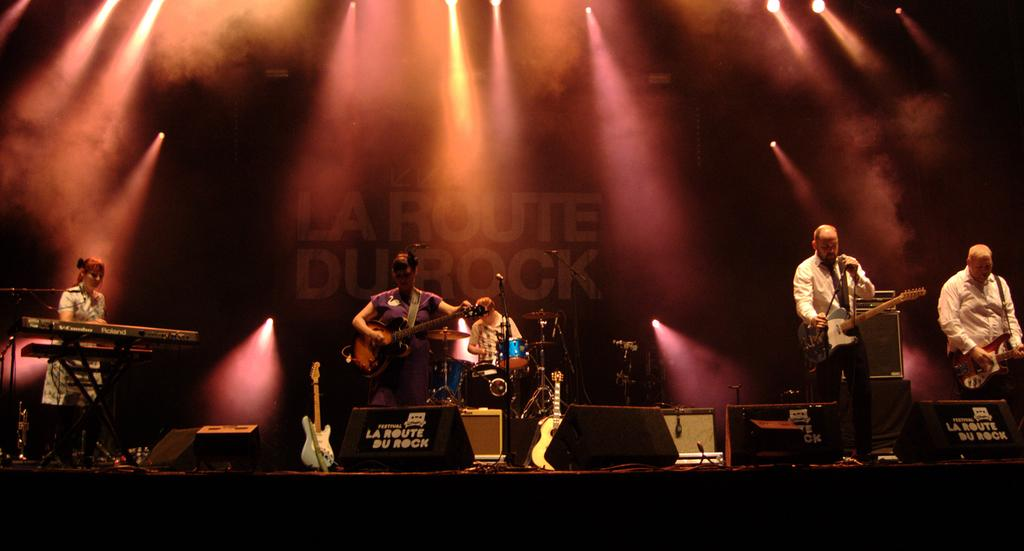What are the persons in the image doing? The persons in the image are standing and holding musical instruments. What else can be seen in the image besides the persons holding musical instruments? There are musical instruments in the background of the image. Can you describe the person in the background of the image? There is a person in the background of the image, but no specific details about them are provided. What can be seen in the background of the image that is not a person or musical instrument? There are lights visible in the background of the image. What type of cushion is being used for the activity in the image? There is no cushion present in the image, and no activity involving a cushion is depicted. 